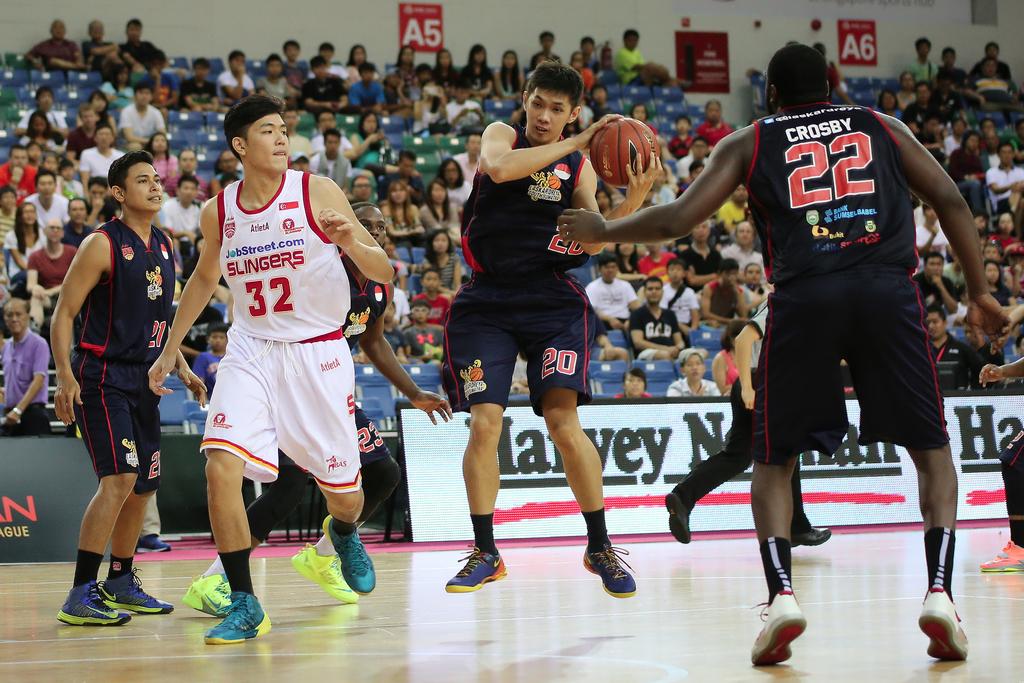What number is on the back of the jersey of the player on the right?
Provide a short and direct response. 22. What number is the person in the white shirt?
Offer a terse response. 32. 